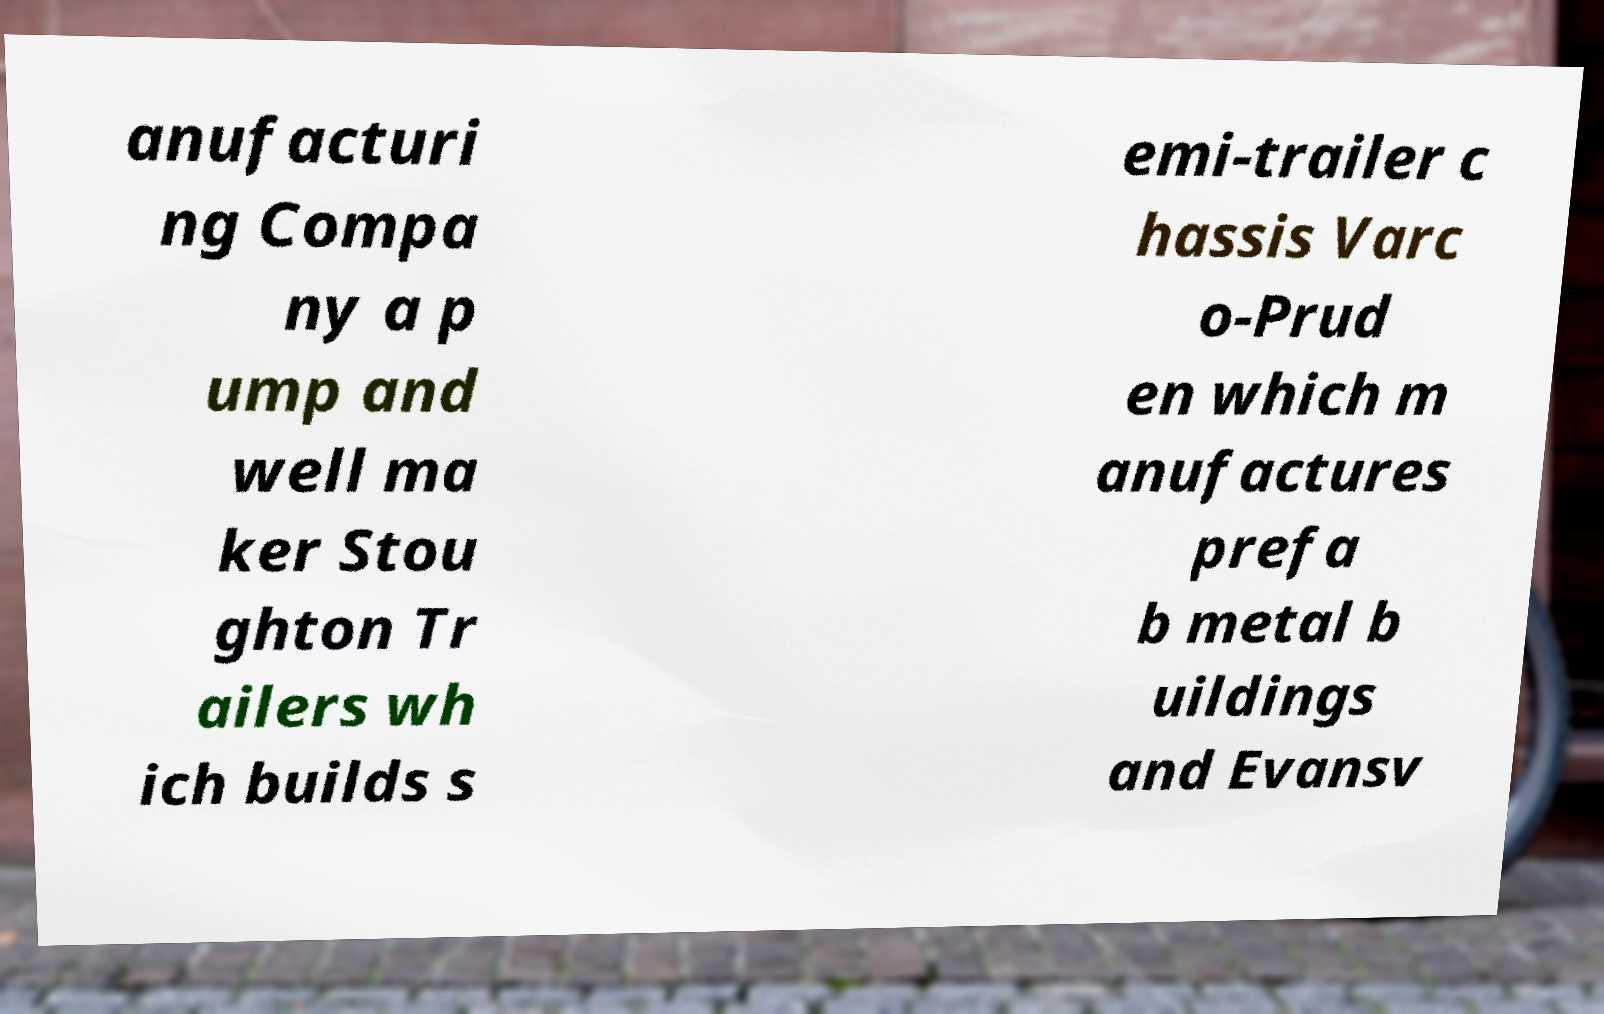Can you read and provide the text displayed in the image?This photo seems to have some interesting text. Can you extract and type it out for me? anufacturi ng Compa ny a p ump and well ma ker Stou ghton Tr ailers wh ich builds s emi-trailer c hassis Varc o-Prud en which m anufactures prefa b metal b uildings and Evansv 